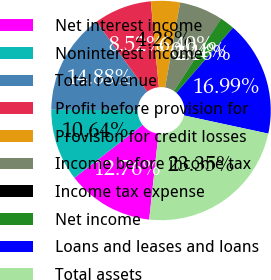<chart> <loc_0><loc_0><loc_500><loc_500><pie_chart><fcel>Net interest income<fcel>Noninterest income<fcel>Total revenue<fcel>Profit before provision for<fcel>Provision for credit losses<fcel>Income before income tax<fcel>Income tax expense<fcel>Net income<fcel>Loans and leases and loans<fcel>Total assets<nl><fcel>12.76%<fcel>10.64%<fcel>14.88%<fcel>8.52%<fcel>4.28%<fcel>6.4%<fcel>0.04%<fcel>2.16%<fcel>16.99%<fcel>23.35%<nl></chart> 